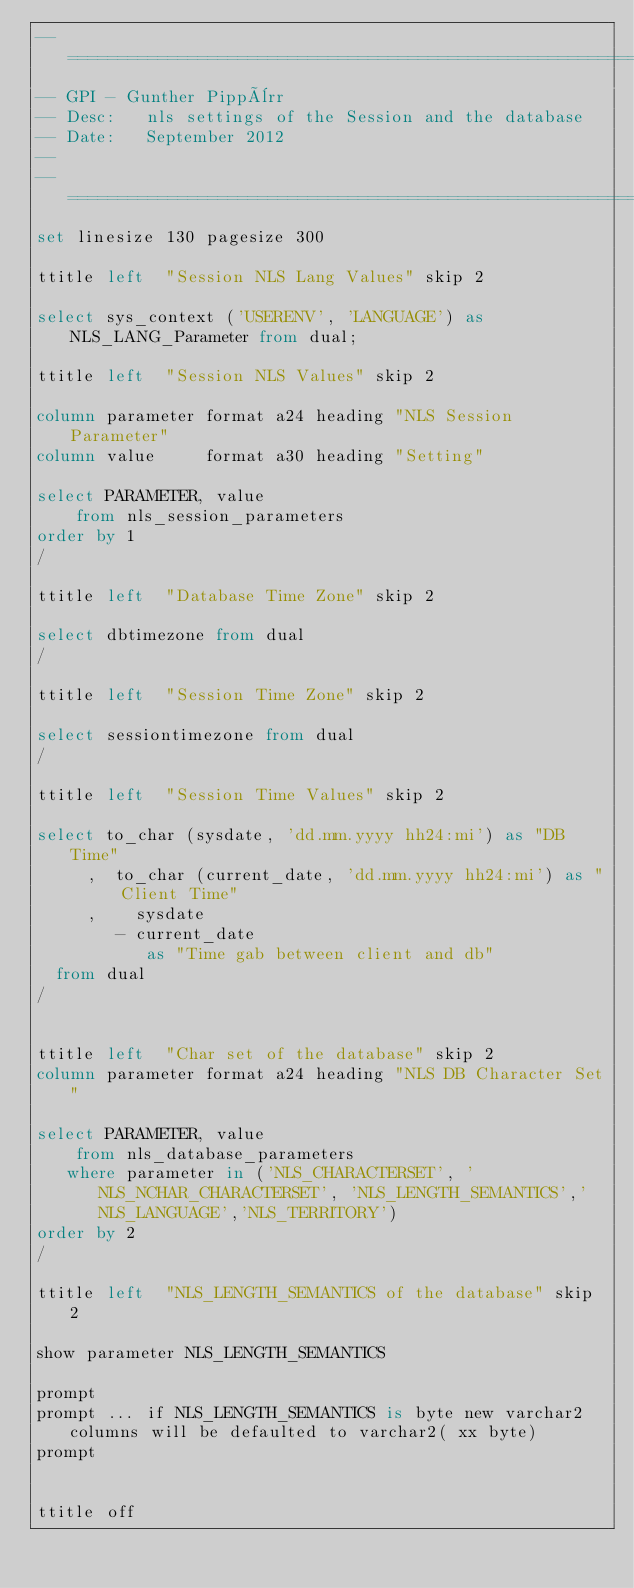<code> <loc_0><loc_0><loc_500><loc_500><_SQL_>--==============================================================================
-- GPI - Gunther Pippèrr
-- Desc:   nls settings of the Session and the database
-- Date:   September 2012
--
--==============================================================================
set linesize 130 pagesize 300 

ttitle left  "Session NLS Lang Values" skip 2

select sys_context ('USERENV', 'LANGUAGE') as NLS_LANG_Parameter from dual;

ttitle left  "Session NLS Values" skip 2

column parameter format a24 heading "NLS Session Parameter"
column value     format a30 heading "Setting"

select PARAMETER, value
    from nls_session_parameters
order by 1
/

ttitle left  "Database Time Zone" skip 2

select dbtimezone from dual
/

ttitle left  "Session Time Zone" skip 2

select sessiontimezone from dual
/

ttitle left  "Session Time Values" skip 2

select to_char (sysdate, 'dd.mm.yyyy hh24:mi') as "DB Time"
     ,  to_char (current_date, 'dd.mm.yyyy hh24:mi') as "Client Time"
     ,    sysdate
        - current_date
           as "Time gab between client and db"
  from dual
/


ttitle left  "Char set of the database" skip 2
column parameter format a24 heading "NLS DB Character Set"

select PARAMETER, value
    from nls_database_parameters
   where parameter in ('NLS_CHARACTERSET', 'NLS_NCHAR_CHARACTERSET', 'NLS_LENGTH_SEMANTICS','NLS_LANGUAGE','NLS_TERRITORY')
order by 2
/

ttitle left  "NLS_LENGTH_SEMANTICS of the database" skip 2

show parameter NLS_LENGTH_SEMANTICS

prompt
prompt ... if NLS_LENGTH_SEMANTICS is byte new varchar2 columns will be defaulted to varchar2( xx byte)
prompt


ttitle off</code> 